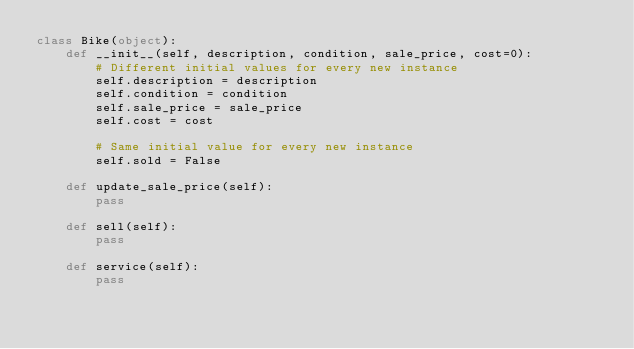<code> <loc_0><loc_0><loc_500><loc_500><_Python_>class Bike(object):
    def __init__(self, description, condition, sale_price, cost=0):
        # Different initial values for every new instance
        self.description = description
        self.condition = condition
        self.sale_price = sale_price
        self.cost = cost

        # Same initial value for every new instance
        self.sold = False

    def update_sale_price(self):
        pass

    def sell(self):
        pass

    def service(self):
        pass
</code> 